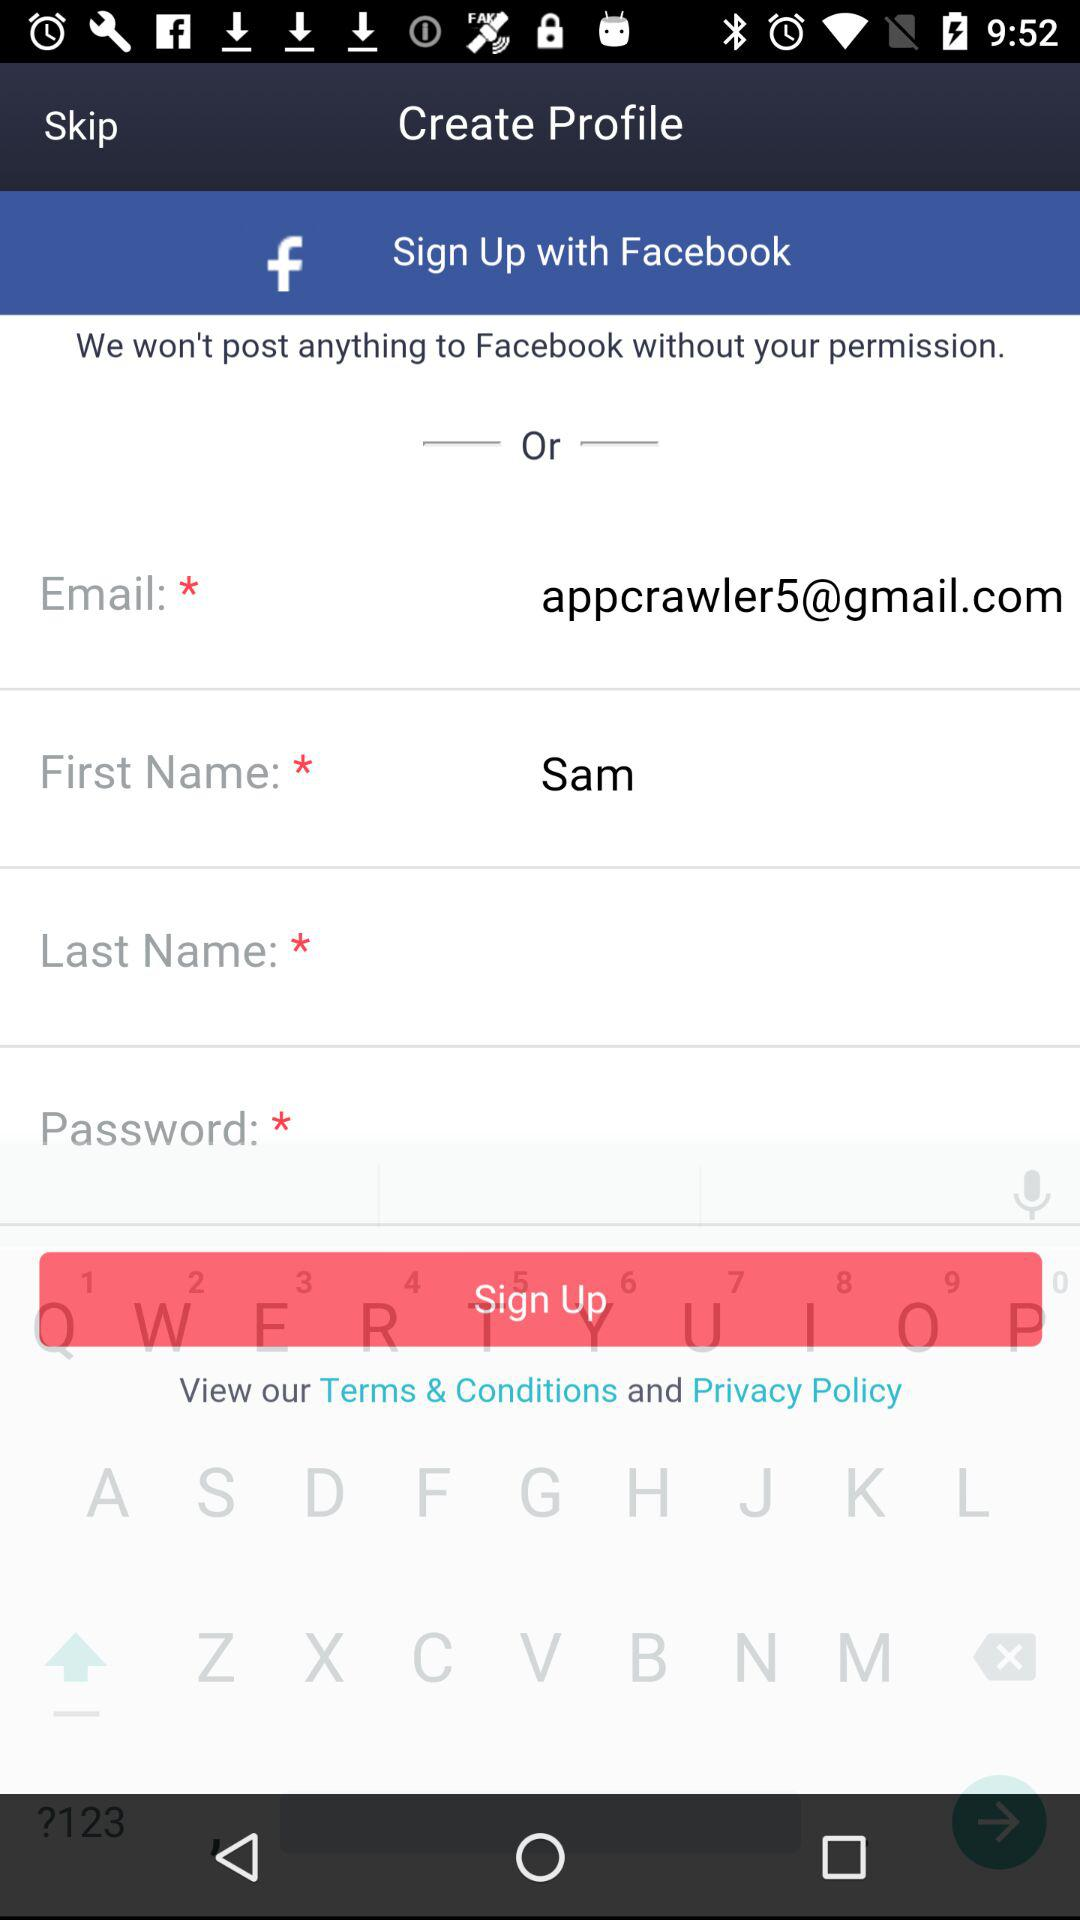What is the email address? The email address is appcrawler5@gmail.com. 